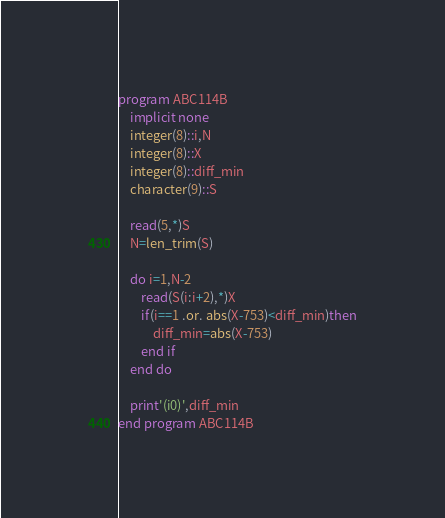Convert code to text. <code><loc_0><loc_0><loc_500><loc_500><_FORTRAN_>program ABC114B
    implicit none
    integer(8)::i,N
    integer(8)::X
    integer(8)::diff_min
    character(9)::S

    read(5,*)S
    N=len_trim(S)

    do i=1,N-2
        read(S(i:i+2),*)X
        if(i==1 .or. abs(X-753)<diff_min)then
            diff_min=abs(X-753)
        end if
    end do

    print'(i0)',diff_min
end program ABC114B</code> 